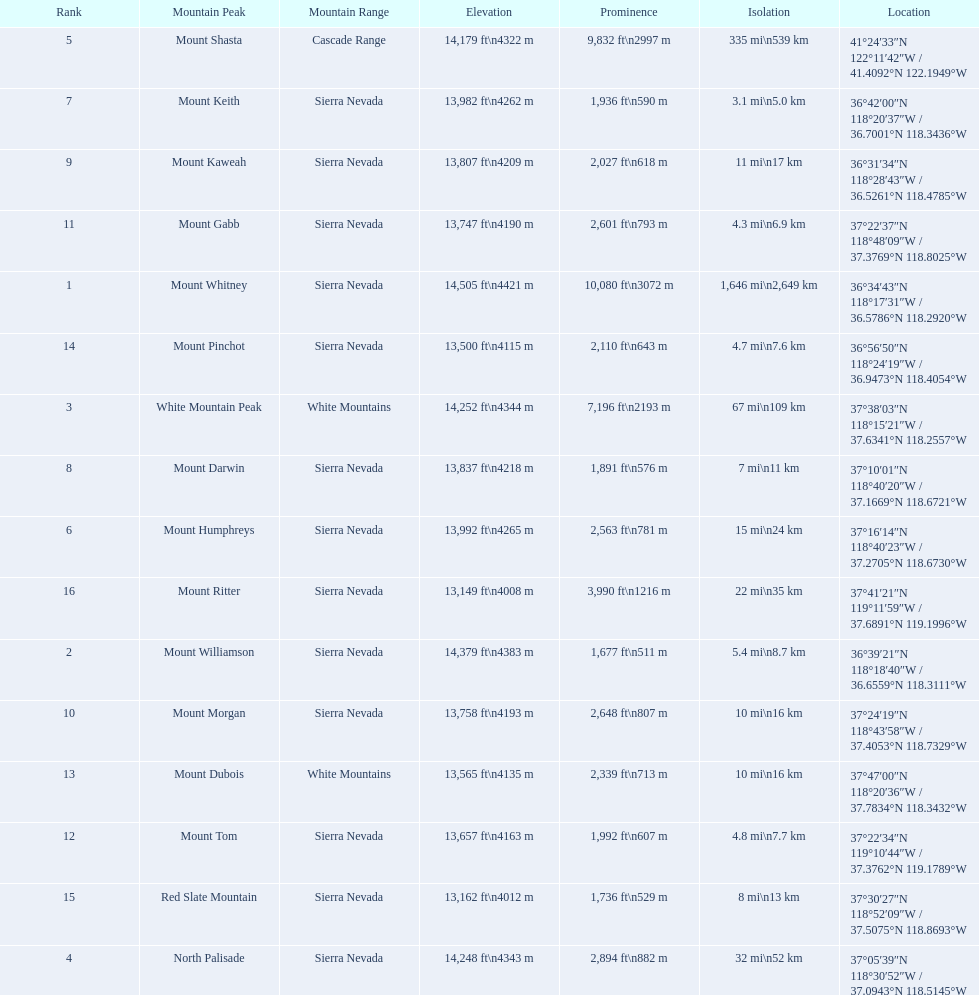What are the prominence lengths higher than 10,000 feet? 10,080 ft\n3072 m. What mountain peak has a prominence of 10,080 feet? Mount Whitney. 